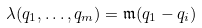<formula> <loc_0><loc_0><loc_500><loc_500>\lambda ( q _ { 1 } , \dots , q _ { m } ) = \mathfrak { m } ( q _ { 1 } - q _ { i } )</formula> 